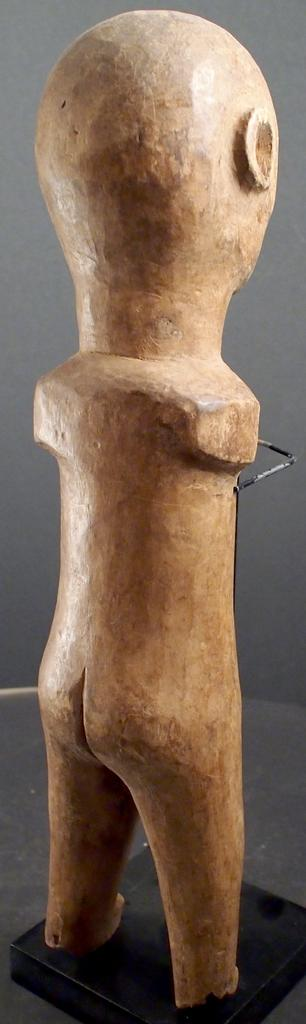What is the main subject in the center of the image? There is a statue in the center of the image. What can be seen in the background of the image? There is a wall in the background of the image. What type of plastic material is used to create the snow in the image? There is no snow or plastic material present in the image; it features a statue and a wall in the background. 